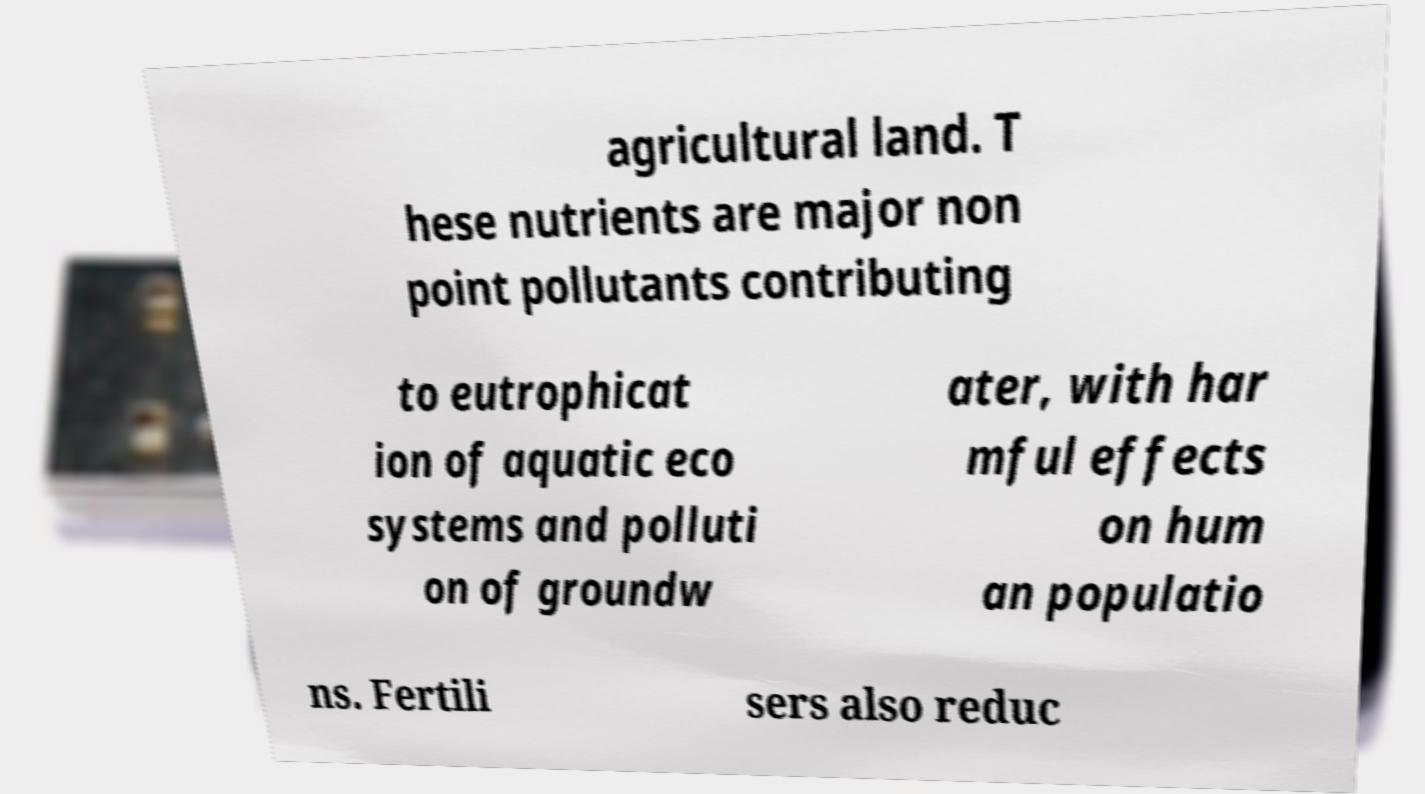I need the written content from this picture converted into text. Can you do that? agricultural land. T hese nutrients are major non point pollutants contributing to eutrophicat ion of aquatic eco systems and polluti on of groundw ater, with har mful effects on hum an populatio ns. Fertili sers also reduc 